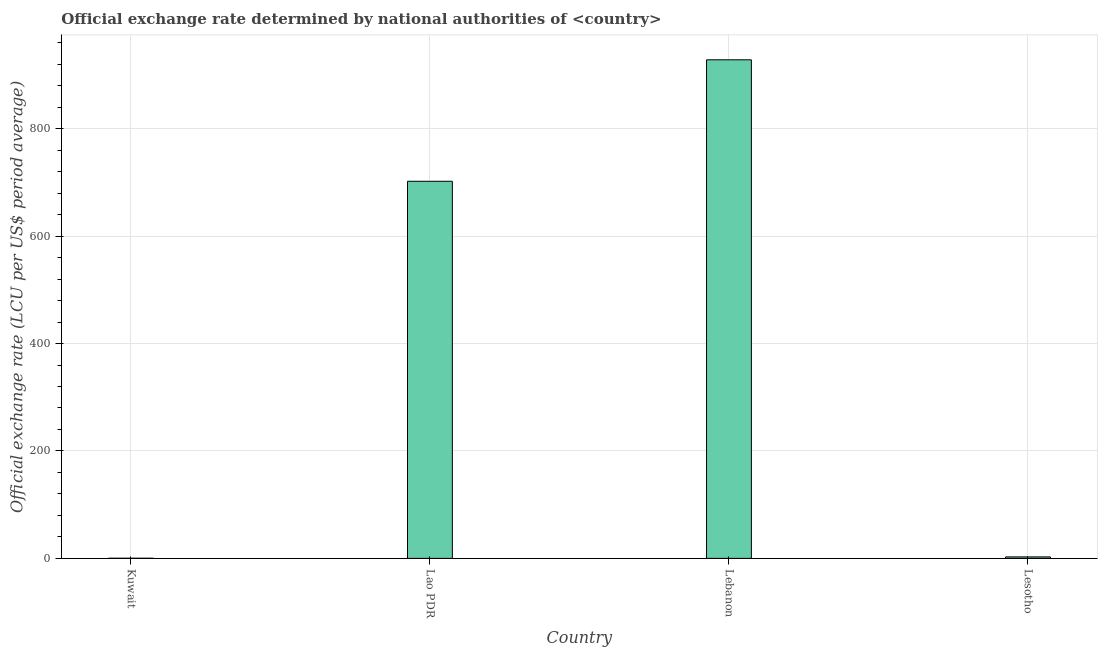Does the graph contain grids?
Provide a short and direct response. Yes. What is the title of the graph?
Your answer should be very brief. Official exchange rate determined by national authorities of <country>. What is the label or title of the X-axis?
Offer a terse response. Country. What is the label or title of the Y-axis?
Your response must be concise. Official exchange rate (LCU per US$ period average). What is the official exchange rate in Lebanon?
Offer a very short reply. 928.23. Across all countries, what is the maximum official exchange rate?
Your response must be concise. 928.23. Across all countries, what is the minimum official exchange rate?
Offer a terse response. 0.28. In which country was the official exchange rate maximum?
Offer a very short reply. Lebanon. In which country was the official exchange rate minimum?
Keep it short and to the point. Kuwait. What is the sum of the official exchange rate?
Offer a terse response. 1633.36. What is the difference between the official exchange rate in Lao PDR and Lesotho?
Offer a very short reply. 699.32. What is the average official exchange rate per country?
Provide a short and direct response. 408.34. What is the median official exchange rate?
Provide a succinct answer. 352.42. In how many countries, is the official exchange rate greater than 280 ?
Offer a terse response. 2. What is the ratio of the official exchange rate in Kuwait to that in Lebanon?
Provide a succinct answer. 0. What is the difference between the highest and the second highest official exchange rate?
Your answer should be very brief. 226.14. What is the difference between the highest and the lowest official exchange rate?
Your answer should be compact. 927.94. How many bars are there?
Keep it short and to the point. 4. What is the difference between two consecutive major ticks on the Y-axis?
Your answer should be compact. 200. What is the Official exchange rate (LCU per US$ period average) of Kuwait?
Provide a succinct answer. 0.28. What is the Official exchange rate (LCU per US$ period average) in Lao PDR?
Your answer should be compact. 702.08. What is the Official exchange rate (LCU per US$ period average) in Lebanon?
Provide a short and direct response. 928.23. What is the Official exchange rate (LCU per US$ period average) in Lesotho?
Your response must be concise. 2.76. What is the difference between the Official exchange rate (LCU per US$ period average) in Kuwait and Lao PDR?
Keep it short and to the point. -701.8. What is the difference between the Official exchange rate (LCU per US$ period average) in Kuwait and Lebanon?
Your answer should be very brief. -927.94. What is the difference between the Official exchange rate (LCU per US$ period average) in Kuwait and Lesotho?
Give a very brief answer. -2.48. What is the difference between the Official exchange rate (LCU per US$ period average) in Lao PDR and Lebanon?
Give a very brief answer. -226.14. What is the difference between the Official exchange rate (LCU per US$ period average) in Lao PDR and Lesotho?
Offer a terse response. 699.32. What is the difference between the Official exchange rate (LCU per US$ period average) in Lebanon and Lesotho?
Ensure brevity in your answer.  925.47. What is the ratio of the Official exchange rate (LCU per US$ period average) in Kuwait to that in Lebanon?
Keep it short and to the point. 0. What is the ratio of the Official exchange rate (LCU per US$ period average) in Kuwait to that in Lesotho?
Your answer should be compact. 0.1. What is the ratio of the Official exchange rate (LCU per US$ period average) in Lao PDR to that in Lebanon?
Your response must be concise. 0.76. What is the ratio of the Official exchange rate (LCU per US$ period average) in Lao PDR to that in Lesotho?
Provide a short and direct response. 254.26. What is the ratio of the Official exchange rate (LCU per US$ period average) in Lebanon to that in Lesotho?
Provide a succinct answer. 336.15. 